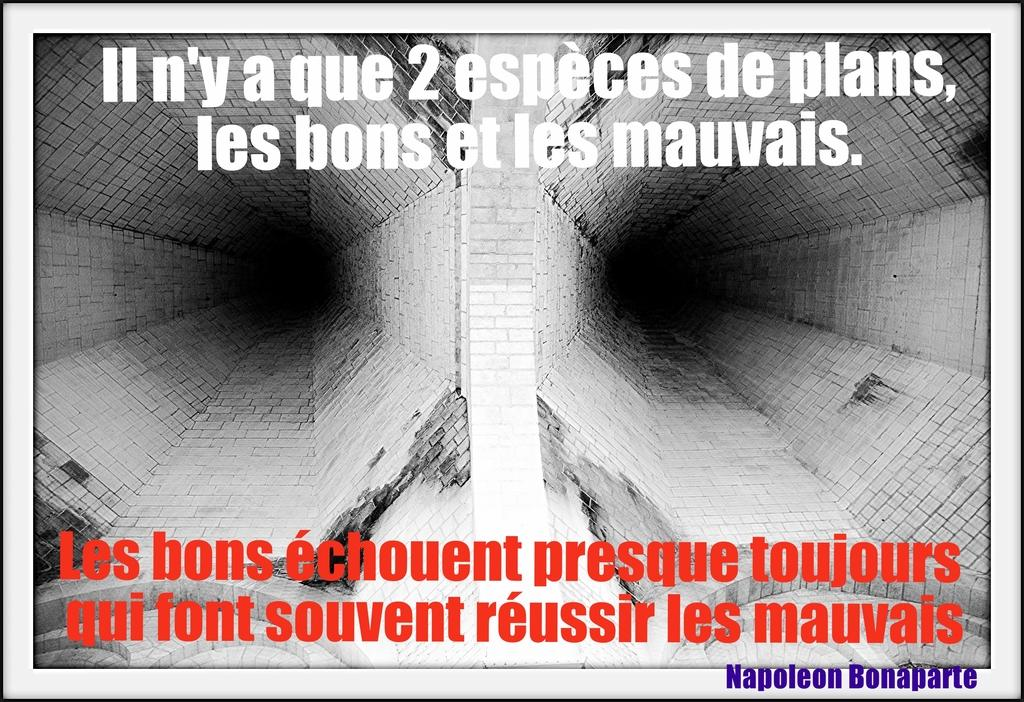<image>
Render a clear and concise summary of the photo. a quote on a photo from Napoleon Bonaparte 